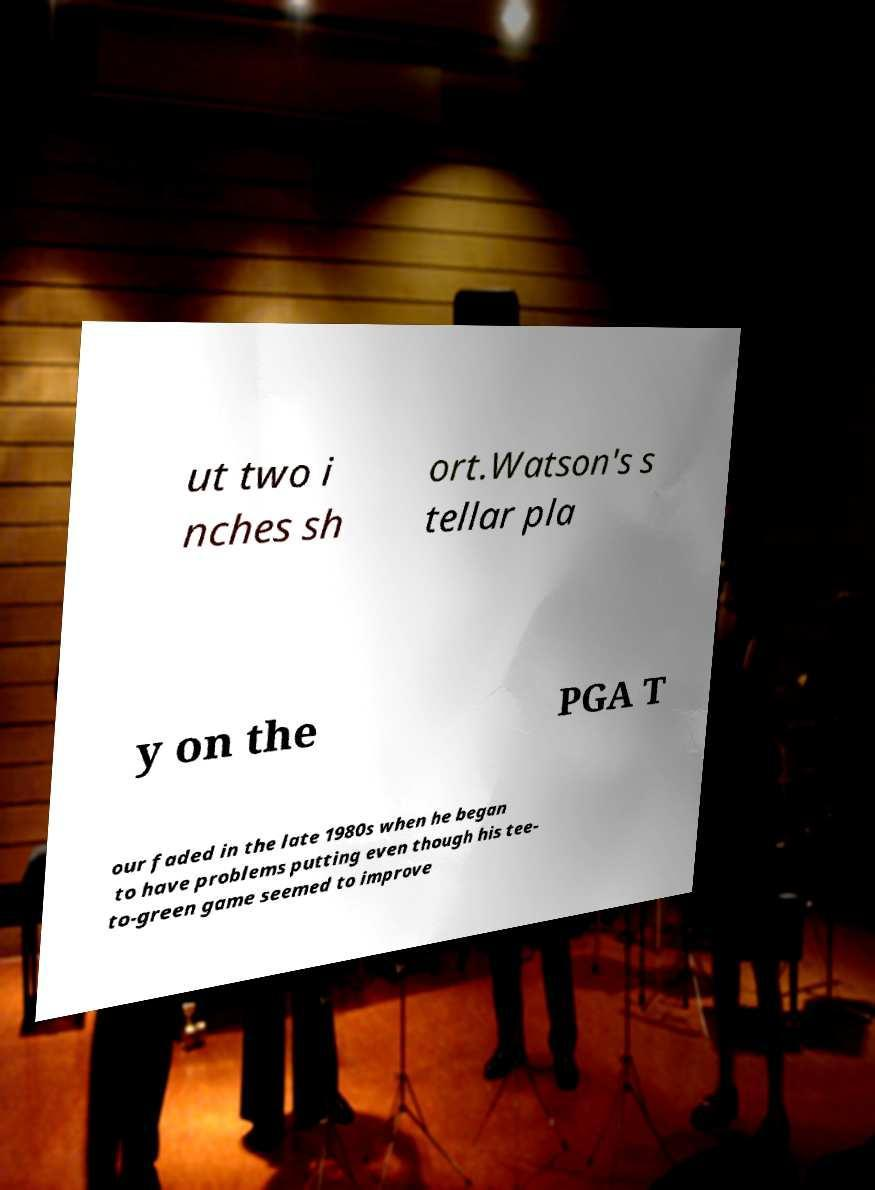For documentation purposes, I need the text within this image transcribed. Could you provide that? ut two i nches sh ort.Watson's s tellar pla y on the PGA T our faded in the late 1980s when he began to have problems putting even though his tee- to-green game seemed to improve 